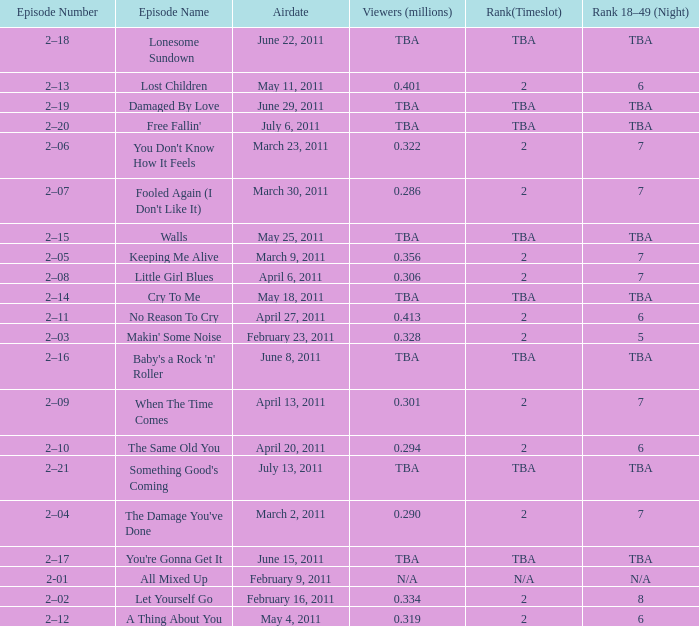What is the total rank on airdate march 30, 2011? 1.0. 